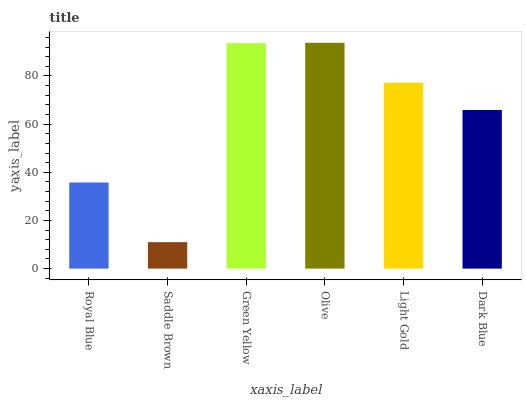Is Saddle Brown the minimum?
Answer yes or no. Yes. Is Olive the maximum?
Answer yes or no. Yes. Is Green Yellow the minimum?
Answer yes or no. No. Is Green Yellow the maximum?
Answer yes or no. No. Is Green Yellow greater than Saddle Brown?
Answer yes or no. Yes. Is Saddle Brown less than Green Yellow?
Answer yes or no. Yes. Is Saddle Brown greater than Green Yellow?
Answer yes or no. No. Is Green Yellow less than Saddle Brown?
Answer yes or no. No. Is Light Gold the high median?
Answer yes or no. Yes. Is Dark Blue the low median?
Answer yes or no. Yes. Is Green Yellow the high median?
Answer yes or no. No. Is Saddle Brown the low median?
Answer yes or no. No. 